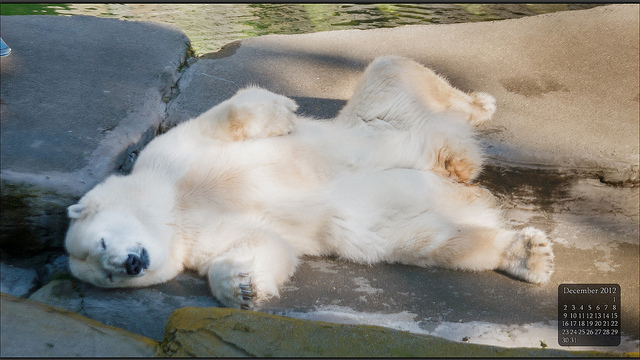Identify the text displayed in this image. December 2012 8 6 11 26 29 22 21 19 17 16 15 13 11 9 4 